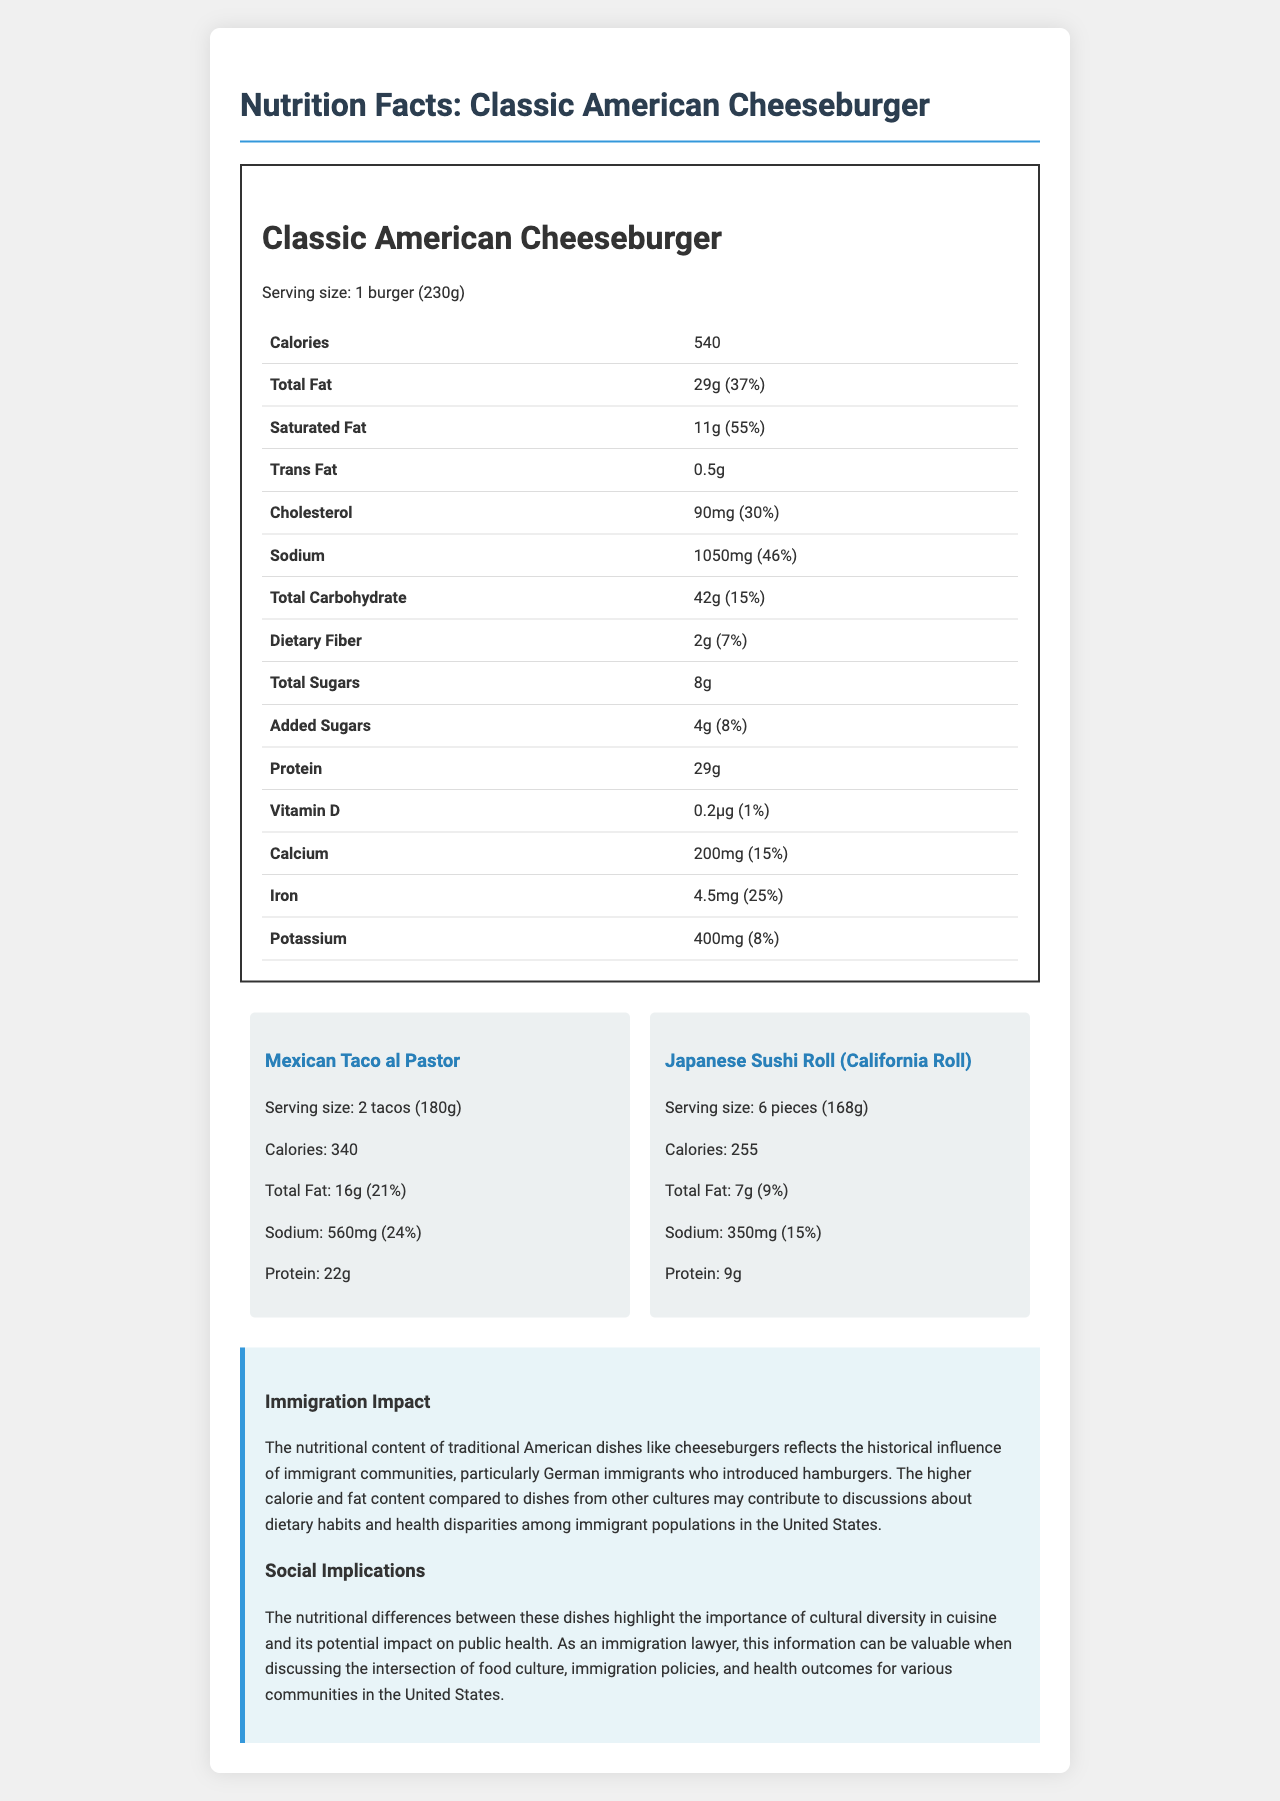What is the serving size of the Classic American Cheeseburger? The serving size is explicitly stated as "1 burger (230g)" in the nutrition label.
Answer: 1 burger (230g) How many calories are there in a Mexican Taco al Pastor serving? The calories for a serving of Mexican Taco al Pastor are listed as 340.
Answer: 340 Which dish has the higher total fat content, Classic American Cheeseburger or Japanese Sushi Roll? The Classic American Cheeseburger has 29g of total fat, while the Japanese Sushi Roll has 7g.
Answer: Classic American Cheeseburger How much sodium does the Classic American Cheeseburger contain? The sodium content is listed as 1050mg for the Classic American Cheeseburger.
Answer: 1050mg What percentage of the daily value of saturated fat does the Classic American Cheeseburger provide? The Classic American Cheeseburger provides 55% of the daily value for saturated fat.
Answer: 55% Which dish provides more protein, Mexican Taco al Pastor or Japanese Sushi Roll? A. Mexican Taco al Pastor B. Japanese Sushi Roll The Mexican Taco al Pastor provides 22g of protein, whereas the Japanese Sushi Roll provides only 9g of protein.
Answer: A. Mexican Taco al Pastor Which of the following has the least amount of calories? I. Classic American Cheeseburger II. Mexican Taco al Pastor III. Japanese Sushi Roll The Japanese Sushi Roll has 255 calories, which is less than the 340 calories in Taco al Pastor and 540 calories in the Classic American Cheeseburger.
Answer: III. Japanese Sushi Roll Is the sodium content of the Japanese Sushi Roll less than that of the Classic American Cheeseburger? Yes/No The Japanese Sushi Roll has 350mg of sodium compared to the 1050mg in the Classic American Cheeseburger.
Answer: Yes Summarize the nutritional comparison between the Classic American Cheeseburger and dishes from other cultures. The document presents a detailed nutrition facts label for a Classic American Cheeseburger and compares it with a Mexican Taco al Pastor and a Japanese Sushi Roll. It points out significant differences in calories, fat, sodium, and protein content, reflecting the diverse dietary habits and health considerations across these cuisines.
Answer: The nutritional comparison reveals that the Classic American Cheeseburger is higher in calories, total fat, saturated fat, and sodium compared to the Mexican Taco al Pastor and Japanese Sushi Roll. In contrast, the Taco al Pastor and Sushi Roll have more balanced nutritional profiles, with fewer calories, lower fat content, and less sodium. This highlights the dietary impacts of different cultural dishes and their potential implications for public health. What historical influence is noted regarding the nutritional content of traditional American dishes? The document mentions that the historical influence of German immigrants who introduced hamburgers is reflected in the nutritional content of traditional American dishes like cheeseburgers.
Answer: German immigrants introduced hamburgers How much calcium does the Classic American Cheeseburger contain? The calcium content is listed as 200mg for the Classic American Cheeseburger.
Answer: 200mg What is the serving size for the Japanese Sushi Roll? The serving size is explicitly stated as "6 pieces (168g)" in the comparison section.
Answer: 6 pieces (168g) Where can you find the total sugars content of the Mexican Taco al Pastor? The document does not provide information on the total sugars content for the Mexican Taco al Pastor.
Answer: Cannot be determined 